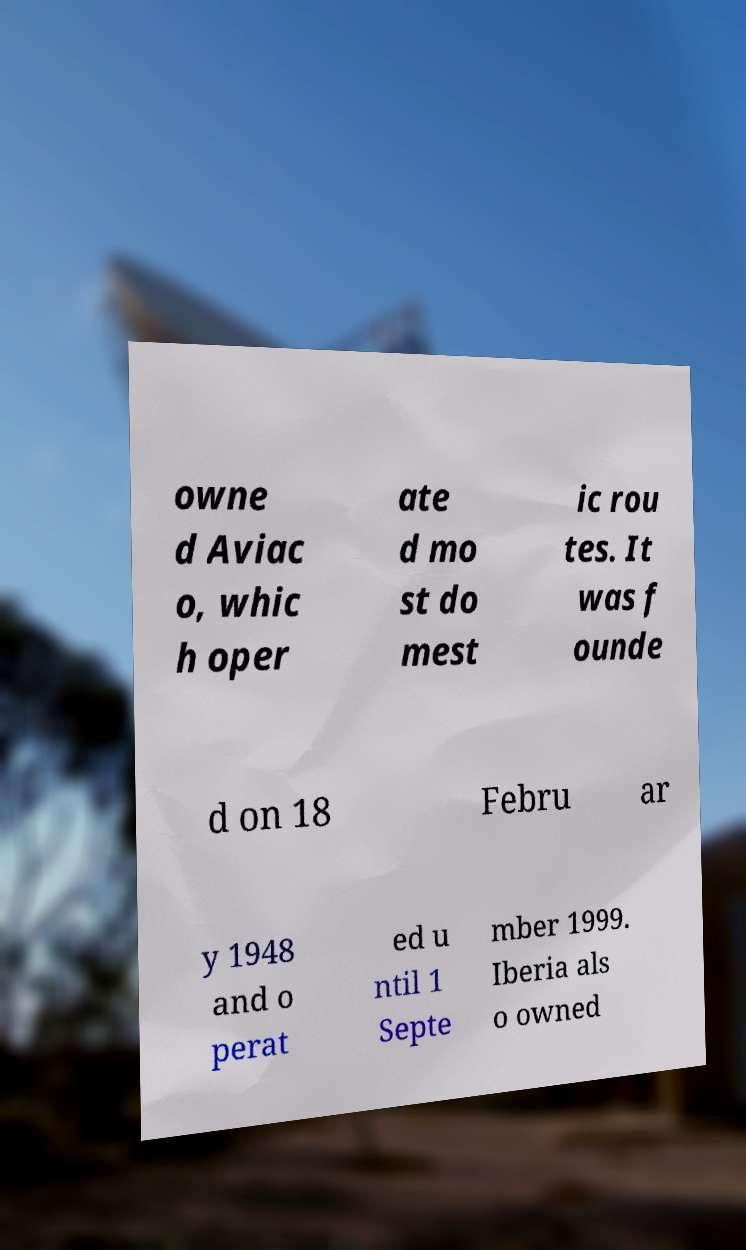Can you read and provide the text displayed in the image?This photo seems to have some interesting text. Can you extract and type it out for me? owne d Aviac o, whic h oper ate d mo st do mest ic rou tes. It was f ounde d on 18 Febru ar y 1948 and o perat ed u ntil 1 Septe mber 1999. Iberia als o owned 